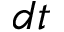<formula> <loc_0><loc_0><loc_500><loc_500>d t</formula> 